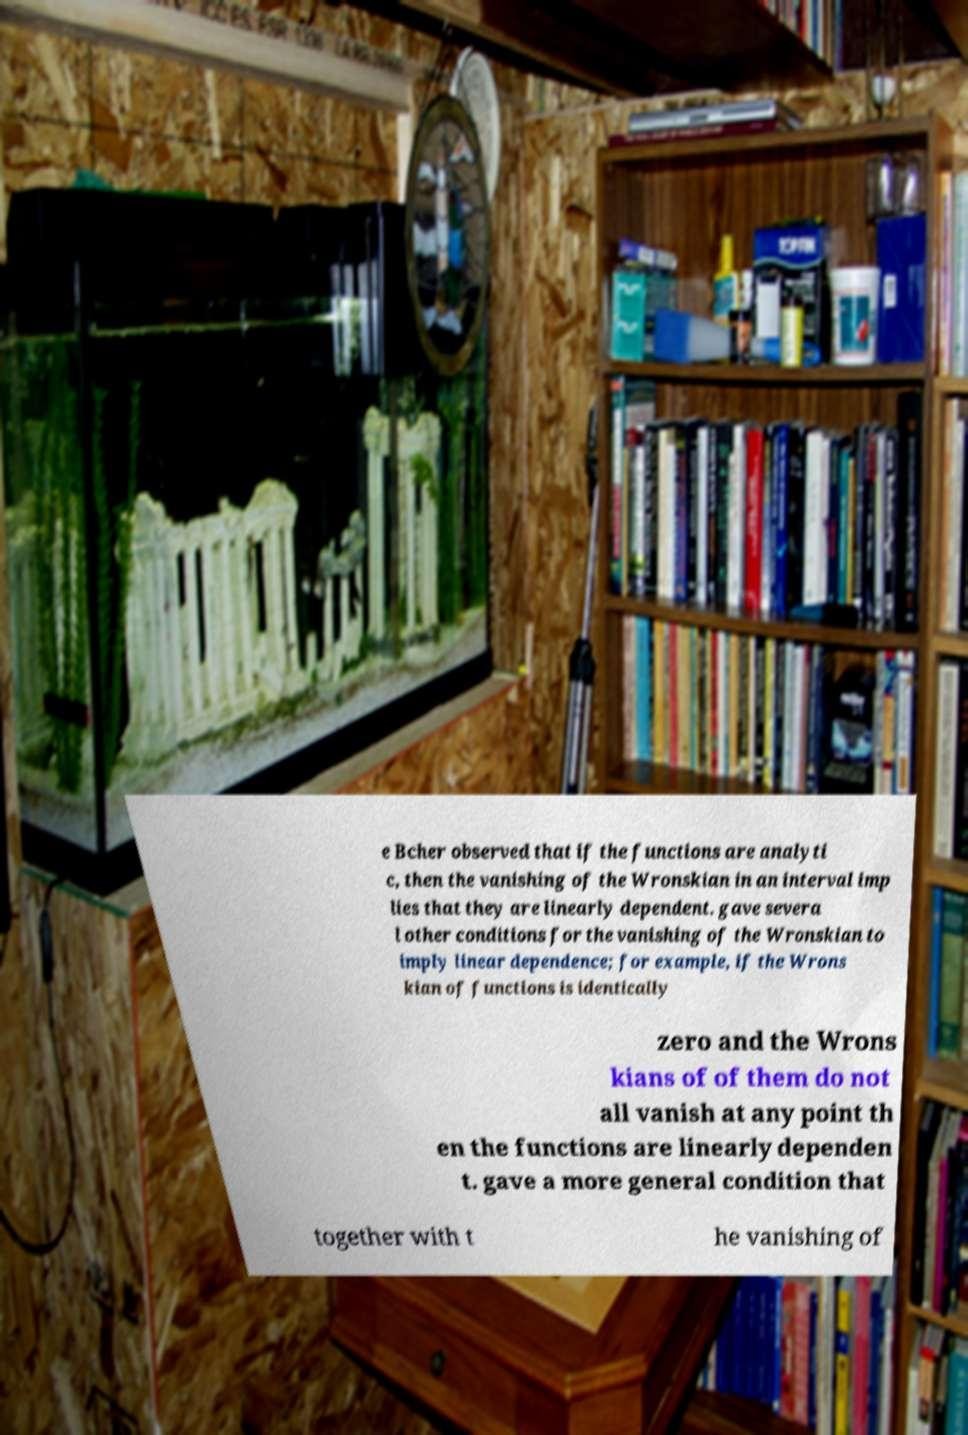Can you read and provide the text displayed in the image?This photo seems to have some interesting text. Can you extract and type it out for me? e Bcher observed that if the functions are analyti c, then the vanishing of the Wronskian in an interval imp lies that they are linearly dependent. gave severa l other conditions for the vanishing of the Wronskian to imply linear dependence; for example, if the Wrons kian of functions is identically zero and the Wrons kians of of them do not all vanish at any point th en the functions are linearly dependen t. gave a more general condition that together with t he vanishing of 